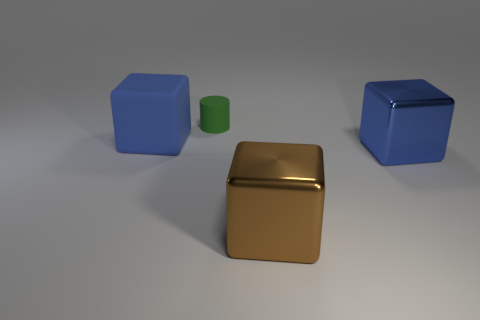Is there anything else that has the same shape as the green object?
Your answer should be compact. No. There is a large matte object; does it have the same color as the big metal cube that is behind the big brown metal cube?
Offer a terse response. Yes. There is a thing that is on the left side of the brown thing and in front of the green rubber thing; what is its shape?
Your answer should be compact. Cube. Are there fewer big rubber blocks than big yellow rubber things?
Offer a very short reply. No. Are any brown spheres visible?
Offer a terse response. No. How many other objects are the same size as the green cylinder?
Keep it short and to the point. 0. Do the large brown block and the blue block that is right of the small green matte object have the same material?
Your answer should be very brief. Yes. Is the number of large blue objects that are left of the large brown metal block the same as the number of small green things that are in front of the tiny green cylinder?
Provide a short and direct response. No. What is the big brown cube made of?
Offer a very short reply. Metal. What color is the metallic thing that is the same size as the brown block?
Keep it short and to the point. Blue. 